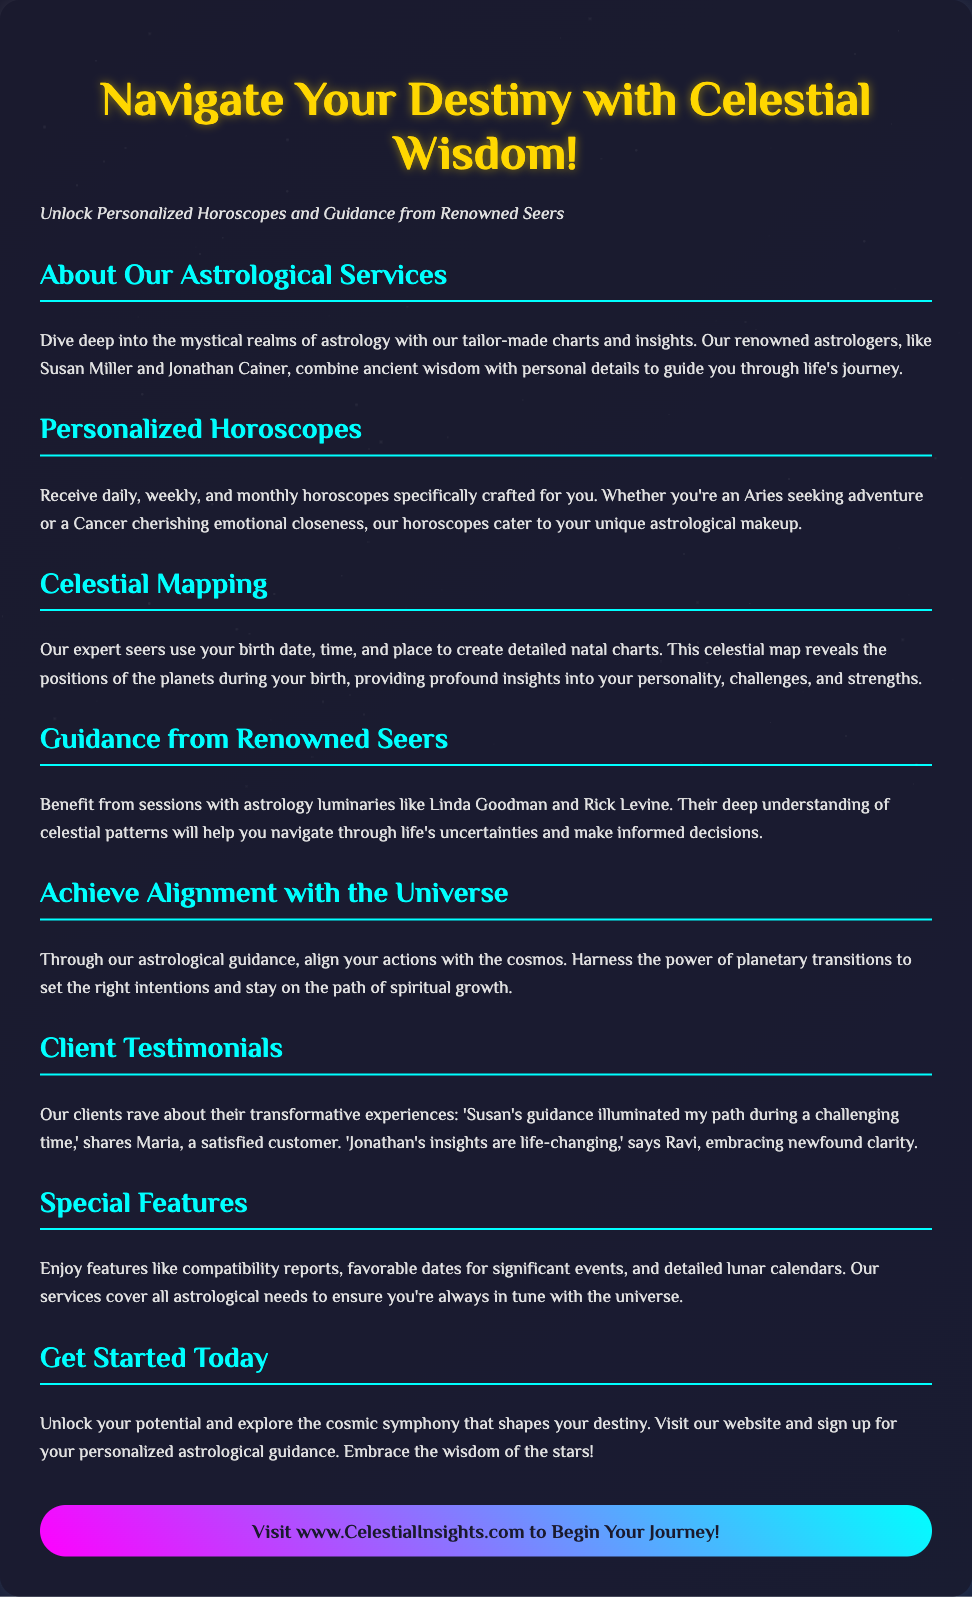What is the title of the advertisement? The title of the advertisement is the main heading that invites the viewer to explore astrology, which is "Navigate Your Destiny with Celestial Wisdom!"
Answer: Navigate Your Destiny with Celestial Wisdom! Who are two renowned astrologers mentioned in the document? The document lists specific astrologers known for their astrological insights, which include Susan Miller and Jonathan Cainer.
Answer: Susan Miller and Jonathan Cainer What type of horoscopes can customers receive? The advertisement highlights several frequencies of personalized horoscopes provided to clients, specifically daily, weekly, and monthly.
Answer: Daily, weekly, and monthly What is the purpose of celestial mapping? The document indicates that celestial mapping is used to create detailed natal charts based on birth details, revealing insights into one's personality and challenges.
Answer: Reveal insights into personality and challenges What can clients achieve with astrological guidance? The advertisement discusses the benefits of aligning one's actions with cosmic happenings, which ultimately assists in spiritual growth.
Answer: Spiritual growth How do clients feel about the services offered? The document includes client testimonials, expressing satisfaction with the transformative experiences they gained from the services.
Answer: Transformative experiences What is the call to action in the advertisement? The advertisement concludes with a strong invitation for users to initiate their astrological journey by visiting a specific website.
Answer: Visit www.CelestialInsights.com What type of reports are included in the special features? The document mentions compatibility reports as one of the special features available for clients.
Answer: Compatibility reports 